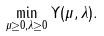<formula> <loc_0><loc_0><loc_500><loc_500>\min _ { \mu \geq 0 , \lambda \geq 0 } \Upsilon ( \mu , \lambda ) .</formula> 